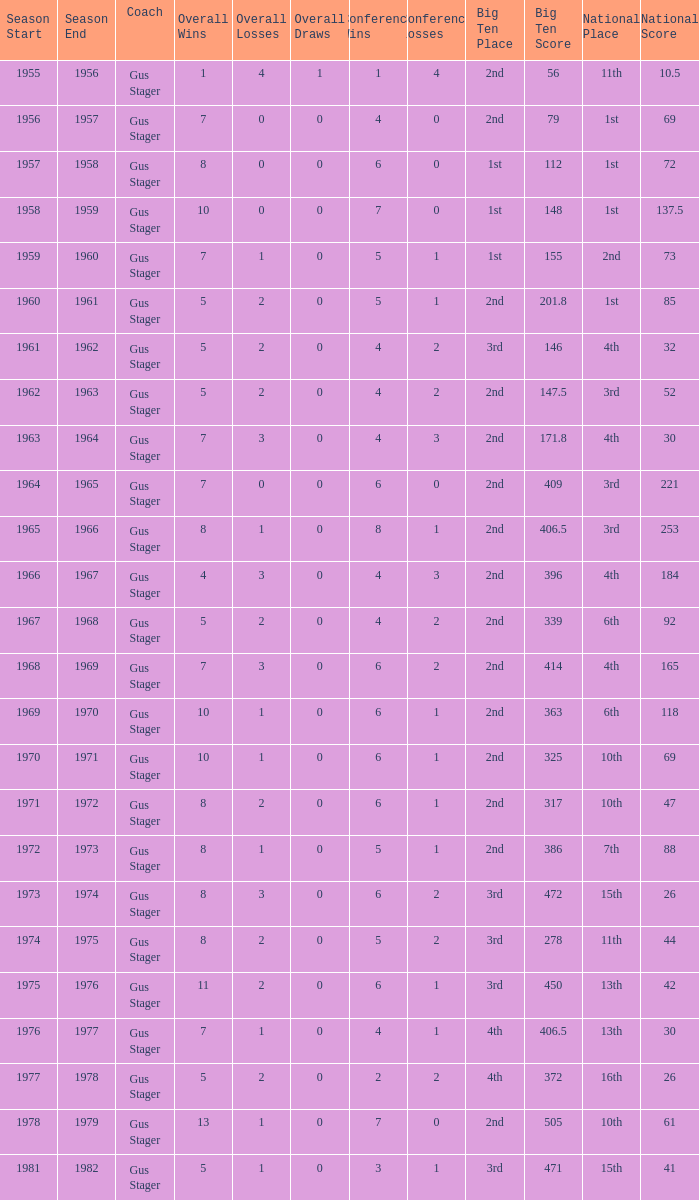What is the Coach with a Big Ten that is 2nd (79)? Gus Stager. 